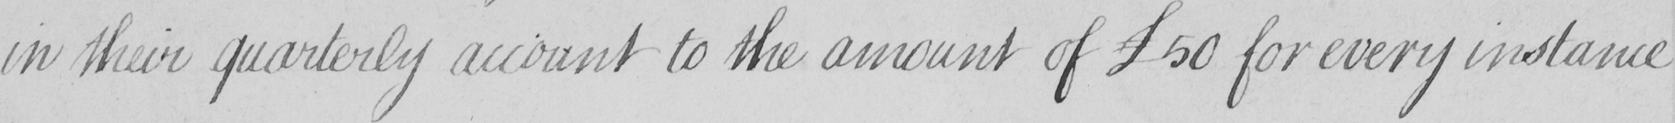Please transcribe the handwritten text in this image. in their quarterly account to the amount of  £50 for every instance 